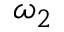Convert formula to latex. <formula><loc_0><loc_0><loc_500><loc_500>\omega _ { 2 }</formula> 